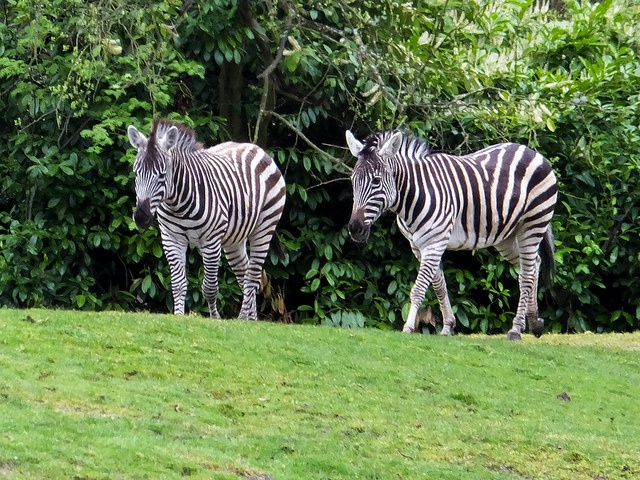Describe the objects in this image and their specific colors. I can see zebra in darkgreen, lightgray, black, darkgray, and gray tones and zebra in darkgreen, lightgray, darkgray, black, and gray tones in this image. 